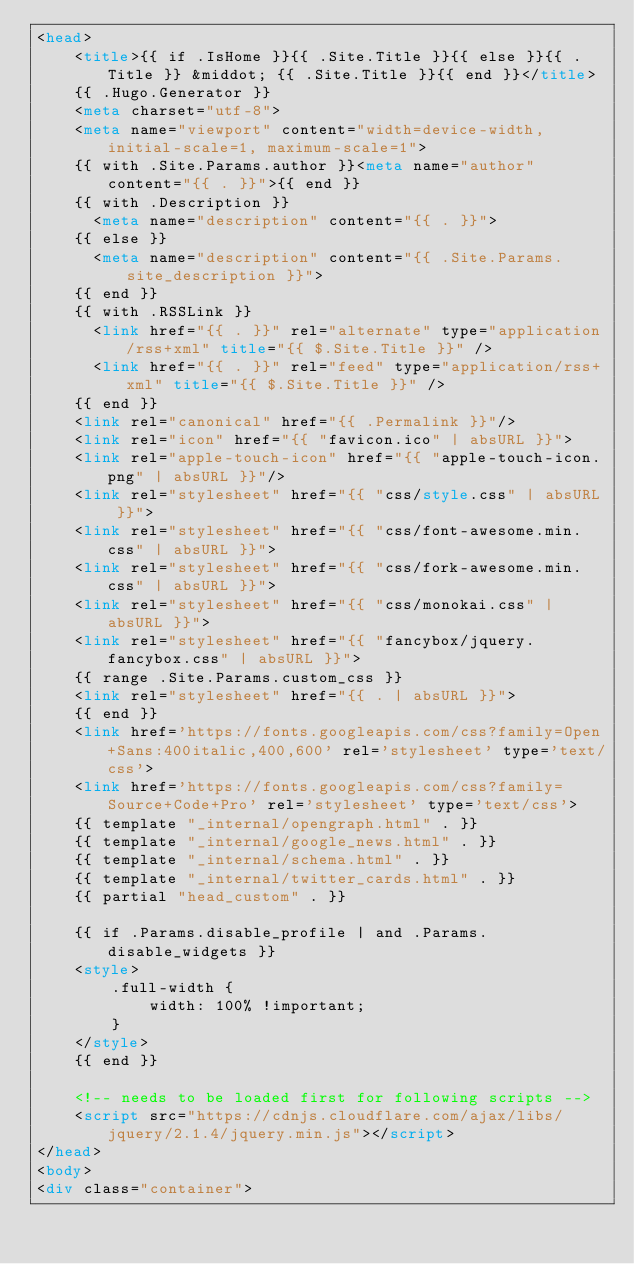<code> <loc_0><loc_0><loc_500><loc_500><_HTML_><head>
    <title>{{ if .IsHome }}{{ .Site.Title }}{{ else }}{{ .Title }} &middot; {{ .Site.Title }}{{ end }}</title>
    {{ .Hugo.Generator }}
    <meta charset="utf-8">
    <meta name="viewport" content="width=device-width, initial-scale=1, maximum-scale=1">
    {{ with .Site.Params.author }}<meta name="author" content="{{ . }}">{{ end }}
    {{ with .Description }}
      <meta name="description" content="{{ . }}">
    {{ else }}
      <meta name="description" content="{{ .Site.Params.site_description }}">
    {{ end }}
    {{ with .RSSLink }}
      <link href="{{ . }}" rel="alternate" type="application/rss+xml" title="{{ $.Site.Title }}" />
      <link href="{{ . }}" rel="feed" type="application/rss+xml" title="{{ $.Site.Title }}" />
    {{ end }}
    <link rel="canonical" href="{{ .Permalink }}"/>
    <link rel="icon" href="{{ "favicon.ico" | absURL }}">
    <link rel="apple-touch-icon" href="{{ "apple-touch-icon.png" | absURL }}"/>
    <link rel="stylesheet" href="{{ "css/style.css" | absURL }}">
    <link rel="stylesheet" href="{{ "css/font-awesome.min.css" | absURL }}">
    <link rel="stylesheet" href="{{ "css/fork-awesome.min.css" | absURL }}">
    <link rel="stylesheet" href="{{ "css/monokai.css" | absURL }}">
    <link rel="stylesheet" href="{{ "fancybox/jquery.fancybox.css" | absURL }}">
    {{ range .Site.Params.custom_css }}
    <link rel="stylesheet" href="{{ . | absURL }}">
    {{ end }}
    <link href='https://fonts.googleapis.com/css?family=Open+Sans:400italic,400,600' rel='stylesheet' type='text/css'>
    <link href='https://fonts.googleapis.com/css?family=Source+Code+Pro' rel='stylesheet' type='text/css'>
    {{ template "_internal/opengraph.html" . }}
    {{ template "_internal/google_news.html" . }}
    {{ template "_internal/schema.html" . }}
    {{ template "_internal/twitter_cards.html" . }}
    {{ partial "head_custom" . }}

    {{ if .Params.disable_profile | and .Params.disable_widgets }}
    <style>
        .full-width {
            width: 100% !important;
        }
    </style>
    {{ end }}

    <!-- needs to be loaded first for following scripts -->
    <script src="https://cdnjs.cloudflare.com/ajax/libs/jquery/2.1.4/jquery.min.js"></script>
</head>
<body>
<div class="container">
</code> 